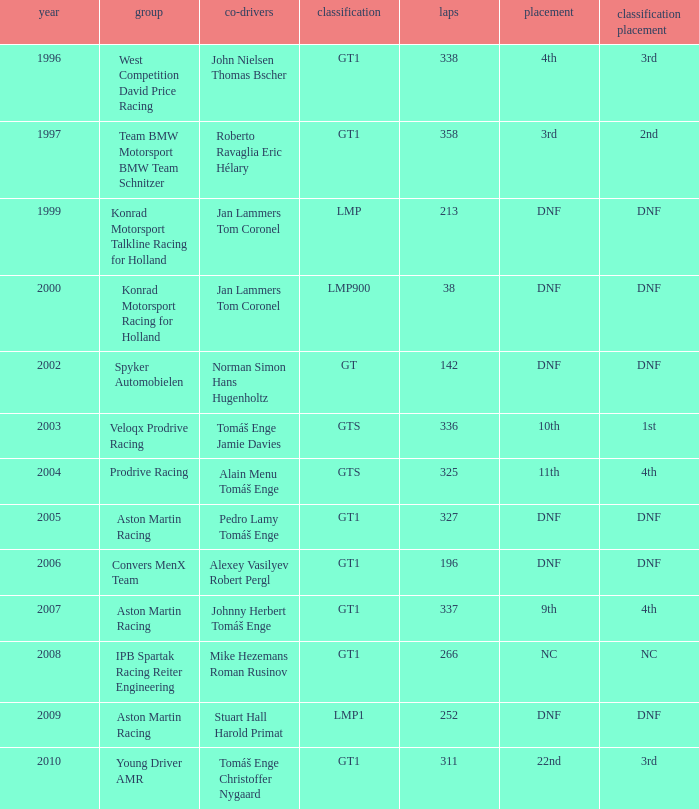In which class had 252 laps and a position of dnf? LMP1. 